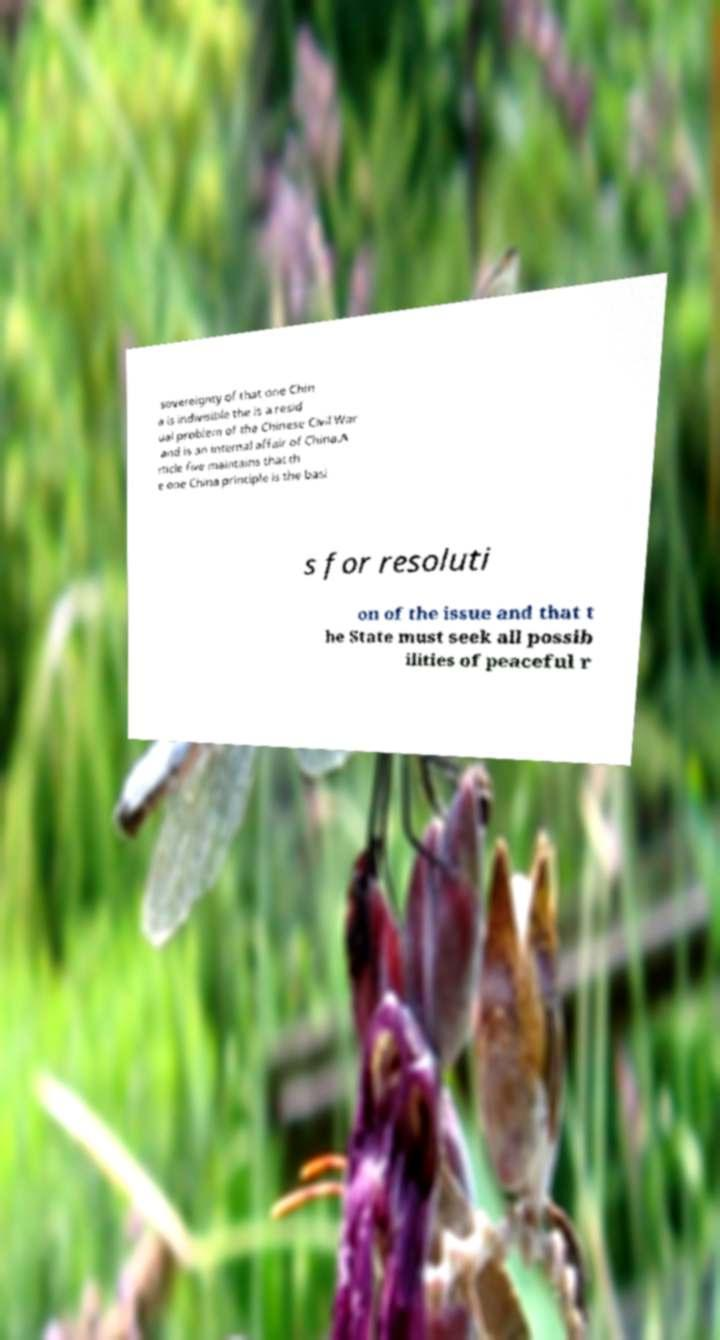Please identify and transcribe the text found in this image. sovereignty of that one Chin a is indivisible the is a resid ual problem of the Chinese Civil War and is an internal affair of China.A rticle five maintains that th e one China principle is the basi s for resoluti on of the issue and that t he State must seek all possib ilities of peaceful r 